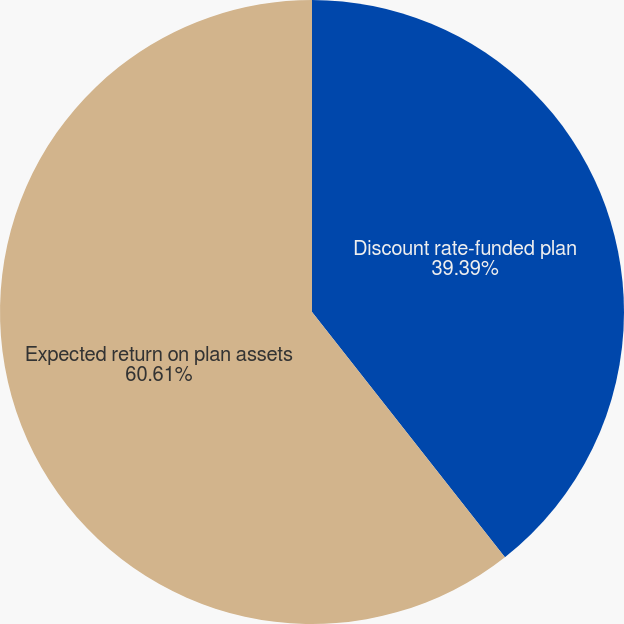Convert chart. <chart><loc_0><loc_0><loc_500><loc_500><pie_chart><fcel>Discount rate-funded plan<fcel>Expected return on plan assets<nl><fcel>39.39%<fcel>60.61%<nl></chart> 